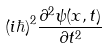<formula> <loc_0><loc_0><loc_500><loc_500>( i \hbar { ) } ^ { 2 } \frac { \partial ^ { 2 } \psi ( x , t ) } { \partial t ^ { 2 } }</formula> 